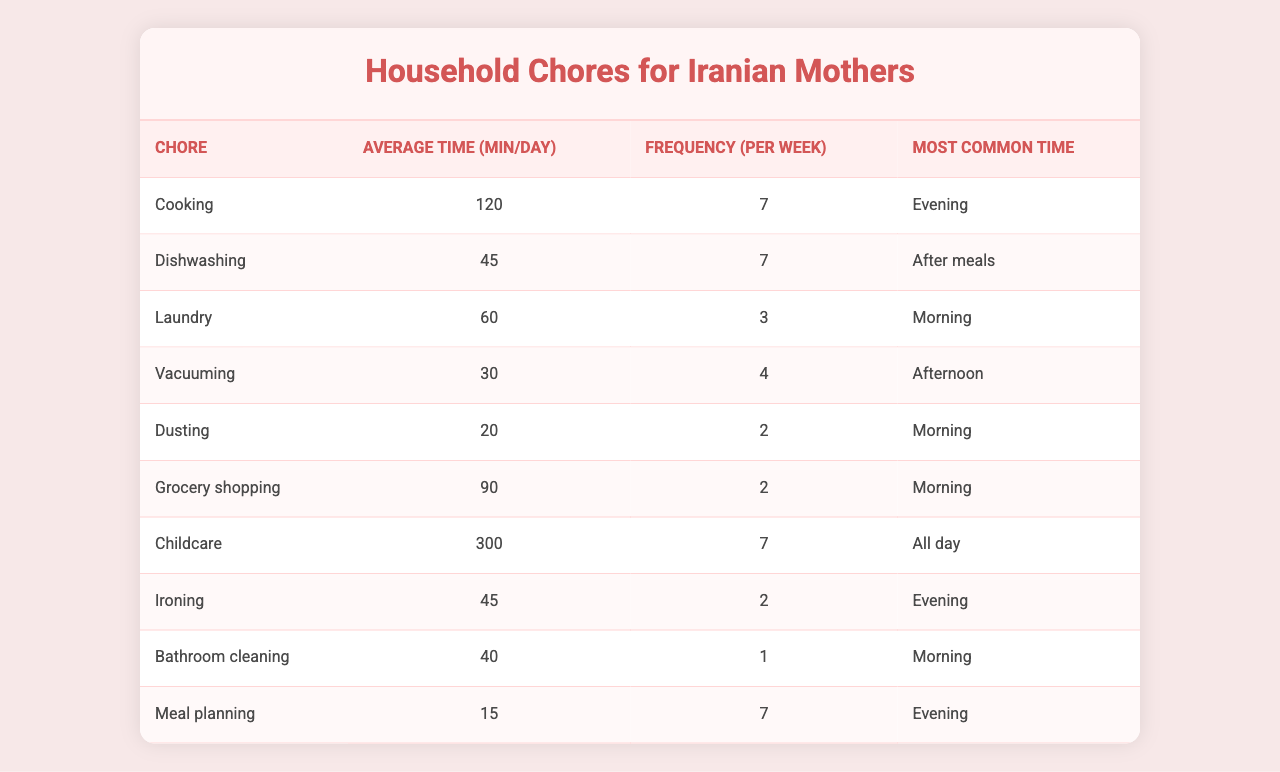What is the average time spent on Cooking per day? The table states that the average time spent on Cooking is 120 minutes.
Answer: 120 minutes How often do mothers typically wash dishes in a week? The table shows that Dishwashing is done 7 times a week.
Answer: 7 times Which chore takes the longest time on average per day? By comparing the average times listed, Childcare takes the longest at 300 minutes.
Answer: Childcare What is the total average time spent on Laundry and Ironing per day? Laundry averages 60 minutes and Ironing averages 45 minutes, so the total is 60 + 45 = 105 minutes.
Answer: 105 minutes What is the most common time of day for Grocery shopping? The table indicates that Grocery shopping is most commonly done in the Morning.
Answer: Morning Is the average time spent on Dusting greater than the time spent on Vacuuming? Dusting averages 20 minutes and Vacuuming averages 30 minutes, therefore Dusting is less.
Answer: No How many times a week do mothers spend time on Household Chores that occur in the Evening? Cooking and Ironing are done in the Evening, corresponding to 7 and 2 times respectively, totaling 7 + 2 = 9 times.
Answer: 9 times What is the average time spent on Childcare compared to the time spent on Meal planning? Childcare averages 300 minutes and Meal planning averages 15 minutes. So, Childcare takes significantly more time.
Answer: Yes, much more If a mother completes all chores on a day where she does Laundry, what is the total time spent on chores for that day? The daily chores on that day are Cooking (120), Dishwashing (45), Laundry (60), Vacuuming (30), Dusting (20), and Meal planning (15). Adding them gives 120 + 45 + 60 + 30 + 20 + 15 = 290 minutes.
Answer: 290 minutes Are mothers more likely to do vacuuming in the Morning than in the Afternoon? The table shows that Vacuuming occurs mainly in the Afternoon, therefore this statement is false.
Answer: No 